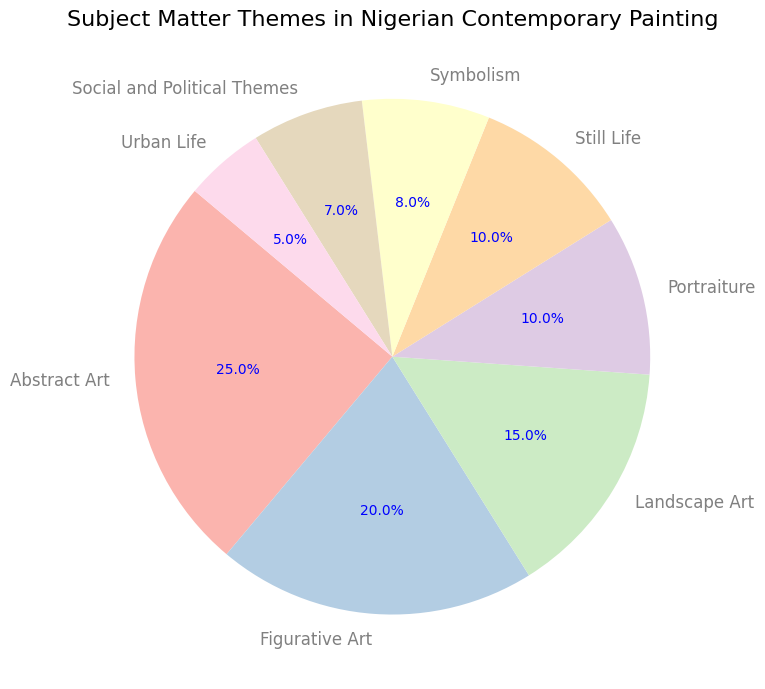What is the most popular subject matter theme in Nigerian contemporary painting according to the pie chart? According to the pie chart, Abstract Art has the largest slice corresponding to 25%, indicating it is the most popular subject matter theme.
Answer: Abstract Art Which subject matter theme has the smallest percentage, and what is this percentage? The pie chart shows that Urban Life has the smallest slice with a percentage of 5%.
Answer: Urban Life, 5% What is the combined percentage of Portraiture and Still Life themes? The percentage for Portraiture is 10% and for Still Life is also 10%. Adding these gives 10% + 10% = 20%.
Answer: 20% Compare the percentages of Symbolism and Social and Political Themes. Which one is higher and by how much? Symbolism has a percentage of 8% while Social and Political Themes have 7%. The difference is 8% - 7% = 1%. Symbolism is higher by 1%.
Answer: Symbolism, by 1% By how much does Figurative Art exceed Urban Life in terms of percentage? Figurative Art has a percentage of 20%, while Urban Life is 5%. The difference is 20% - 5% = 15%.
Answer: 15% Which subject matter themes have percentages greater than the mean percentage? The mean percentage is calculated by adding all percentages and dividing by the number of themes: (25 + 20 + 15 + 10 + 10 + 8 + 7 + 5) / 8 = 100 / 8 = 12.5%. The themes with percentages greater than 12.5% are Abstract Art (25%), Figurative Art (20%), and Landscape Art (15%).
Answer: Abstract Art, Figurative Art, Landscape Art How many subject matter themes have a percentage below 10%? From the pie chart, the themes with percentages below 10% are Symbolism (8%), Social and Political Themes (7%), and Urban Life (5%). This makes a total of 3 themes.
Answer: 3 If you combine the percentages of Abstract Art and Figurative Art, how does this combined percentage compare to the sum of all the other themes combined? The total percentage for Abstract Art and Figurative Art combined is 25% + 20% = 45%. The sum of the percentages of all other themes is 100% - 45% = 55%. Therefore, the combined percentage of the other themes is higher.
Answer: Other themes by 10% Which visual element helps determine the start and end angle of each segment in the pie chart? In the pie chart, the start and end angles are indicated by the orientation and size of each slice, with each theme represented by a distinct colored segment radiating from the center.
Answer: Orientation and size of each slice What percentage does Landscape Art occupy in the pie chart? The pie chart indicates that Landscape Art occupies a slice that corresponds to 15%.
Answer: 15% 